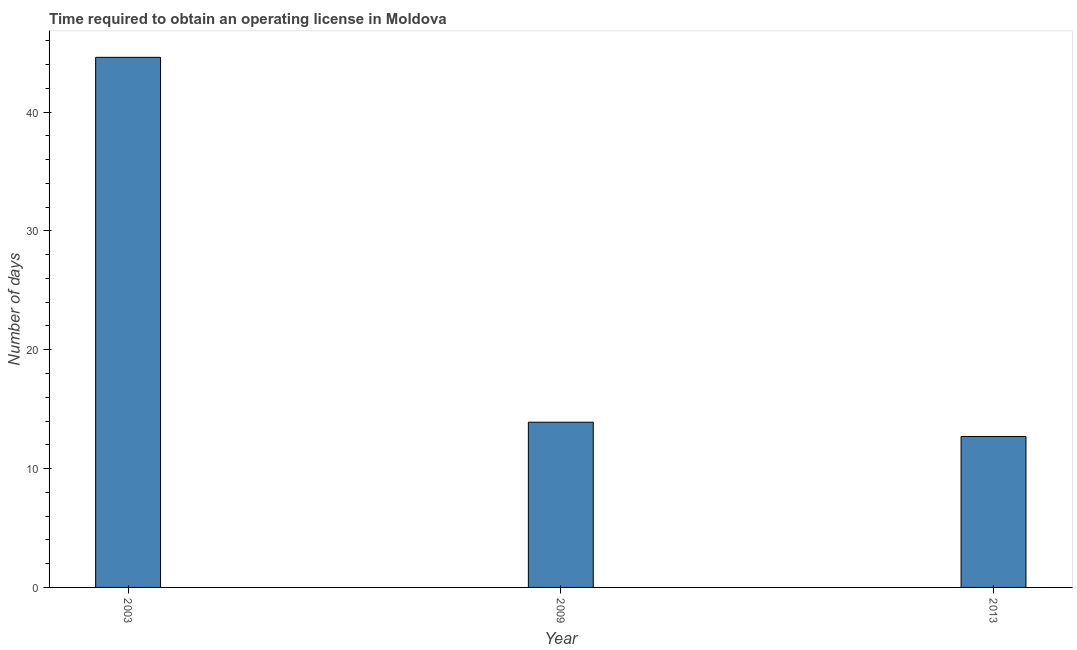What is the title of the graph?
Offer a very short reply. Time required to obtain an operating license in Moldova. What is the label or title of the Y-axis?
Give a very brief answer. Number of days. What is the number of days to obtain operating license in 2013?
Give a very brief answer. 12.7. Across all years, what is the maximum number of days to obtain operating license?
Ensure brevity in your answer.  44.6. Across all years, what is the minimum number of days to obtain operating license?
Ensure brevity in your answer.  12.7. In which year was the number of days to obtain operating license maximum?
Provide a succinct answer. 2003. In which year was the number of days to obtain operating license minimum?
Make the answer very short. 2013. What is the sum of the number of days to obtain operating license?
Give a very brief answer. 71.2. What is the difference between the number of days to obtain operating license in 2003 and 2013?
Your response must be concise. 31.9. What is the average number of days to obtain operating license per year?
Offer a very short reply. 23.73. Do a majority of the years between 2009 and 2013 (inclusive) have number of days to obtain operating license greater than 42 days?
Offer a terse response. No. What is the ratio of the number of days to obtain operating license in 2003 to that in 2013?
Make the answer very short. 3.51. Is the number of days to obtain operating license in 2003 less than that in 2013?
Keep it short and to the point. No. Is the difference between the number of days to obtain operating license in 2003 and 2013 greater than the difference between any two years?
Provide a short and direct response. Yes. What is the difference between the highest and the second highest number of days to obtain operating license?
Keep it short and to the point. 30.7. Is the sum of the number of days to obtain operating license in 2003 and 2009 greater than the maximum number of days to obtain operating license across all years?
Offer a terse response. Yes. What is the difference between the highest and the lowest number of days to obtain operating license?
Offer a terse response. 31.9. How many bars are there?
Give a very brief answer. 3. How many years are there in the graph?
Your answer should be compact. 3. What is the difference between two consecutive major ticks on the Y-axis?
Your response must be concise. 10. What is the Number of days in 2003?
Your answer should be compact. 44.6. What is the difference between the Number of days in 2003 and 2009?
Make the answer very short. 30.7. What is the difference between the Number of days in 2003 and 2013?
Your response must be concise. 31.9. What is the difference between the Number of days in 2009 and 2013?
Make the answer very short. 1.2. What is the ratio of the Number of days in 2003 to that in 2009?
Provide a short and direct response. 3.21. What is the ratio of the Number of days in 2003 to that in 2013?
Offer a terse response. 3.51. What is the ratio of the Number of days in 2009 to that in 2013?
Make the answer very short. 1.09. 